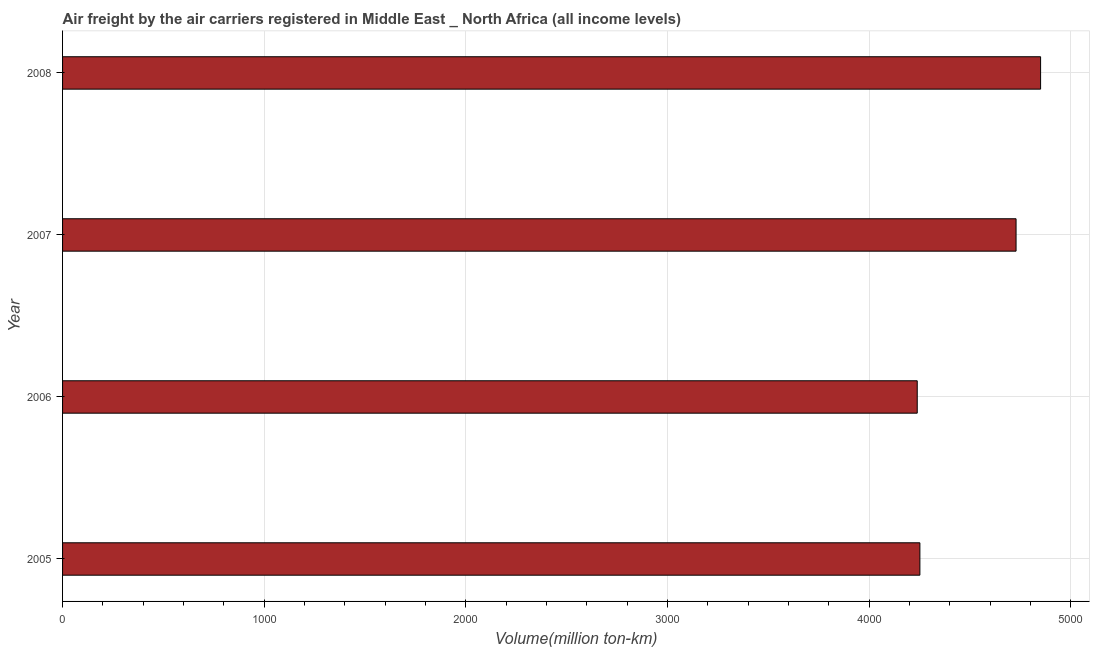Does the graph contain grids?
Ensure brevity in your answer.  Yes. What is the title of the graph?
Provide a succinct answer. Air freight by the air carriers registered in Middle East _ North Africa (all income levels). What is the label or title of the X-axis?
Your answer should be very brief. Volume(million ton-km). What is the air freight in 2005?
Provide a short and direct response. 4252.27. Across all years, what is the maximum air freight?
Give a very brief answer. 4850.95. Across all years, what is the minimum air freight?
Your answer should be compact. 4239.14. In which year was the air freight minimum?
Your answer should be very brief. 2006. What is the sum of the air freight?
Give a very brief answer. 1.81e+04. What is the difference between the air freight in 2006 and 2008?
Your answer should be very brief. -611.81. What is the average air freight per year?
Provide a succinct answer. 4517.91. What is the median air freight?
Provide a short and direct response. 4490.77. Do a majority of the years between 2006 and 2005 (inclusive) have air freight greater than 1200 million ton-km?
Provide a short and direct response. No. What is the ratio of the air freight in 2005 to that in 2007?
Ensure brevity in your answer.  0.9. Is the air freight in 2005 less than that in 2008?
Offer a terse response. Yes. Is the difference between the air freight in 2006 and 2007 greater than the difference between any two years?
Give a very brief answer. No. What is the difference between the highest and the second highest air freight?
Make the answer very short. 121.68. What is the difference between the highest and the lowest air freight?
Give a very brief answer. 611.81. Are all the bars in the graph horizontal?
Your response must be concise. Yes. How many years are there in the graph?
Give a very brief answer. 4. Are the values on the major ticks of X-axis written in scientific E-notation?
Provide a succinct answer. No. What is the Volume(million ton-km) in 2005?
Provide a succinct answer. 4252.27. What is the Volume(million ton-km) in 2006?
Make the answer very short. 4239.14. What is the Volume(million ton-km) in 2007?
Offer a very short reply. 4729.28. What is the Volume(million ton-km) in 2008?
Make the answer very short. 4850.95. What is the difference between the Volume(million ton-km) in 2005 and 2006?
Give a very brief answer. 13.13. What is the difference between the Volume(million ton-km) in 2005 and 2007?
Make the answer very short. -477.01. What is the difference between the Volume(million ton-km) in 2005 and 2008?
Give a very brief answer. -598.68. What is the difference between the Volume(million ton-km) in 2006 and 2007?
Your answer should be compact. -490.14. What is the difference between the Volume(million ton-km) in 2006 and 2008?
Offer a very short reply. -611.81. What is the difference between the Volume(million ton-km) in 2007 and 2008?
Make the answer very short. -121.68. What is the ratio of the Volume(million ton-km) in 2005 to that in 2006?
Keep it short and to the point. 1. What is the ratio of the Volume(million ton-km) in 2005 to that in 2007?
Make the answer very short. 0.9. What is the ratio of the Volume(million ton-km) in 2005 to that in 2008?
Keep it short and to the point. 0.88. What is the ratio of the Volume(million ton-km) in 2006 to that in 2007?
Offer a terse response. 0.9. What is the ratio of the Volume(million ton-km) in 2006 to that in 2008?
Offer a terse response. 0.87. 